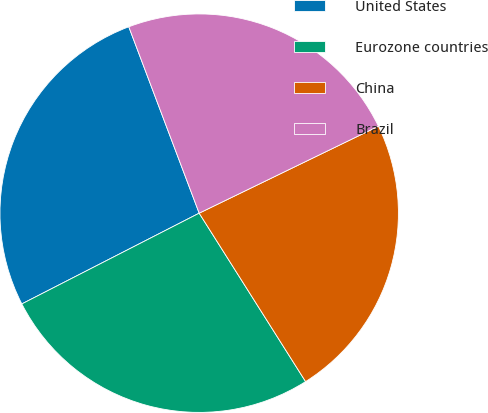Convert chart to OTSL. <chart><loc_0><loc_0><loc_500><loc_500><pie_chart><fcel>United States<fcel>Eurozone countries<fcel>China<fcel>Brazil<nl><fcel>26.78%<fcel>26.44%<fcel>23.22%<fcel>23.56%<nl></chart> 